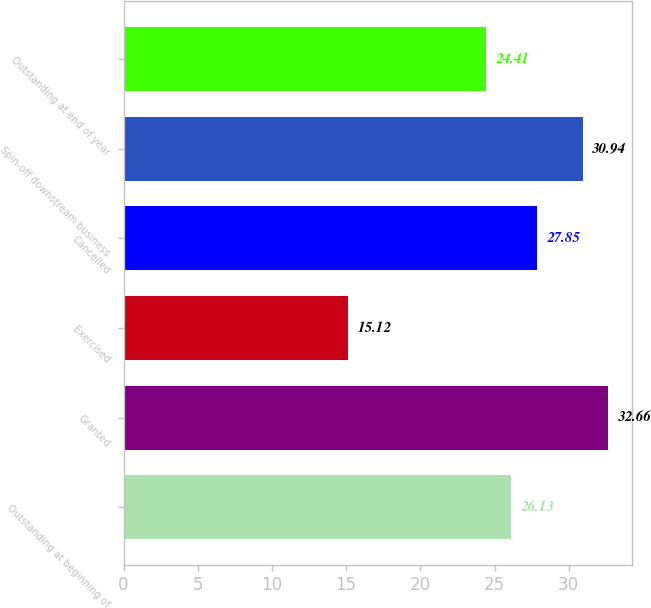Convert chart. <chart><loc_0><loc_0><loc_500><loc_500><bar_chart><fcel>Outstanding at beginning of<fcel>Granted<fcel>Exercised<fcel>Cancelled<fcel>Spin-off downstream business<fcel>Outstanding at end of year<nl><fcel>26.13<fcel>32.66<fcel>15.12<fcel>27.85<fcel>30.94<fcel>24.41<nl></chart> 